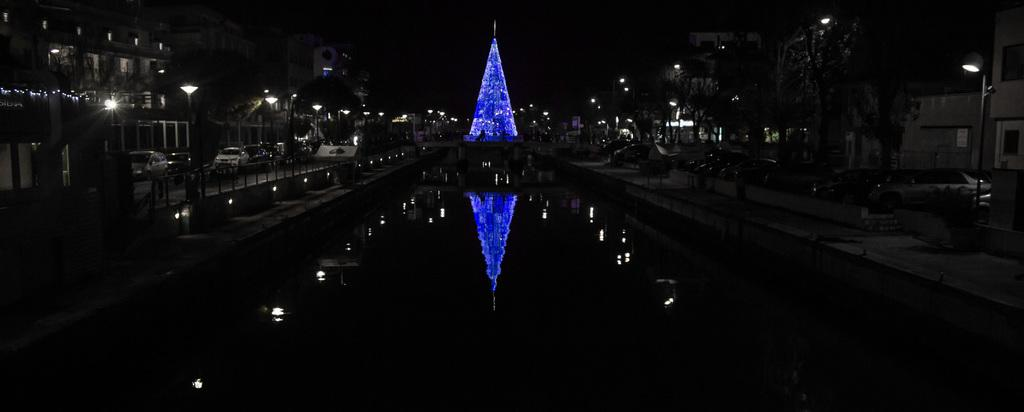What is the primary element visible in the image? There is water in the image. What can be seen on the sides of the image? There are trees, buildings, and light poles on the sides of the image. What is located in the back of the image? There is a tower with lights in the back of the image. How does the tower and lights affect the water in the image? The tower and lights are reflected in the water. How many dimes can be seen floating on the water in the image? There are no dimes visible in the image; it features water, trees, buildings, light poles, and a tower with lights. Can you tell me which queen is looking at the tower in the image? There is no queen present in the image, and the image does not depict anyone looking at the tower. 